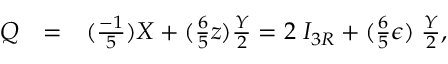Convert formula to latex. <formula><loc_0><loc_0><loc_500><loc_500>\begin{array} { c c l } { Q } & { = } & { { ( \frac { - 1 } { 5 } ) X + ( \frac { 6 } { 5 } z ) { \frac { Y } { 2 } } = 2 \, I _ { 3 R } + ( \frac { 6 } { 5 } \epsilon ) \, { \frac { Y } { 2 } } , } } \end{array}</formula> 